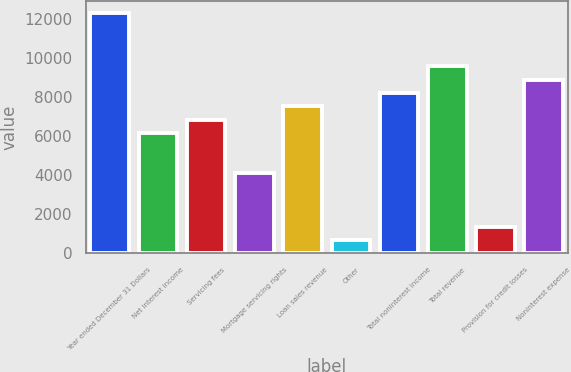<chart> <loc_0><loc_0><loc_500><loc_500><bar_chart><fcel>Year ended December 31 Dollars<fcel>Net interest income<fcel>Servicing fees<fcel>Mortgage servicing rights<fcel>Loan sales revenue<fcel>Other<fcel>Total noninterest income<fcel>Total revenue<fcel>Provision for credit losses<fcel>Noninterest expense<nl><fcel>12311.7<fcel>6156.02<fcel>6839.98<fcel>4104.14<fcel>7523.94<fcel>684.34<fcel>8207.9<fcel>9575.82<fcel>1368.3<fcel>8891.86<nl></chart> 